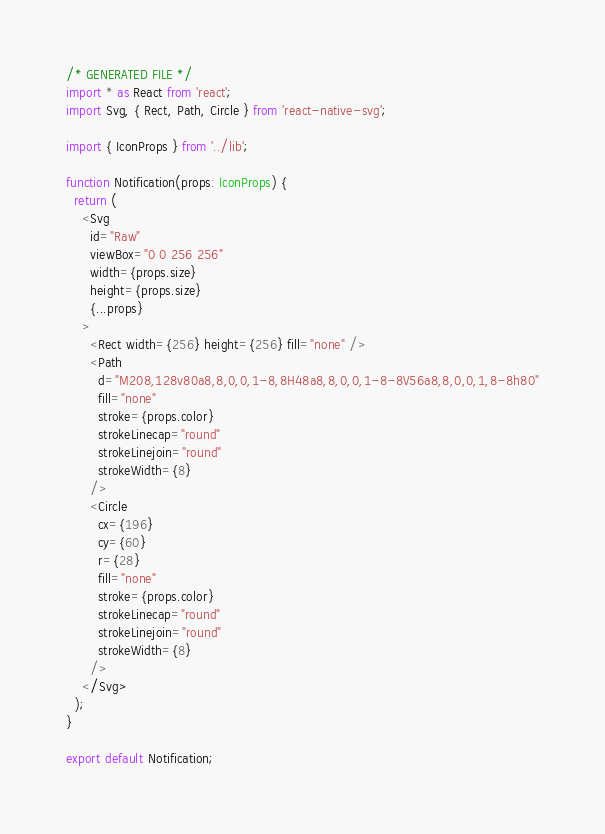Convert code to text. <code><loc_0><loc_0><loc_500><loc_500><_TypeScript_>/* GENERATED FILE */
import * as React from 'react';
import Svg, { Rect, Path, Circle } from 'react-native-svg';

import { IconProps } from '../lib';

function Notification(props: IconProps) {
  return (
    <Svg
      id="Raw"
      viewBox="0 0 256 256"
      width={props.size}
      height={props.size}
      {...props}
    >
      <Rect width={256} height={256} fill="none" />
      <Path
        d="M208,128v80a8,8,0,0,1-8,8H48a8,8,0,0,1-8-8V56a8,8,0,0,1,8-8h80"
        fill="none"
        stroke={props.color}
        strokeLinecap="round"
        strokeLinejoin="round"
        strokeWidth={8}
      />
      <Circle
        cx={196}
        cy={60}
        r={28}
        fill="none"
        stroke={props.color}
        strokeLinecap="round"
        strokeLinejoin="round"
        strokeWidth={8}
      />
    </Svg>
  );
}

export default Notification;
</code> 